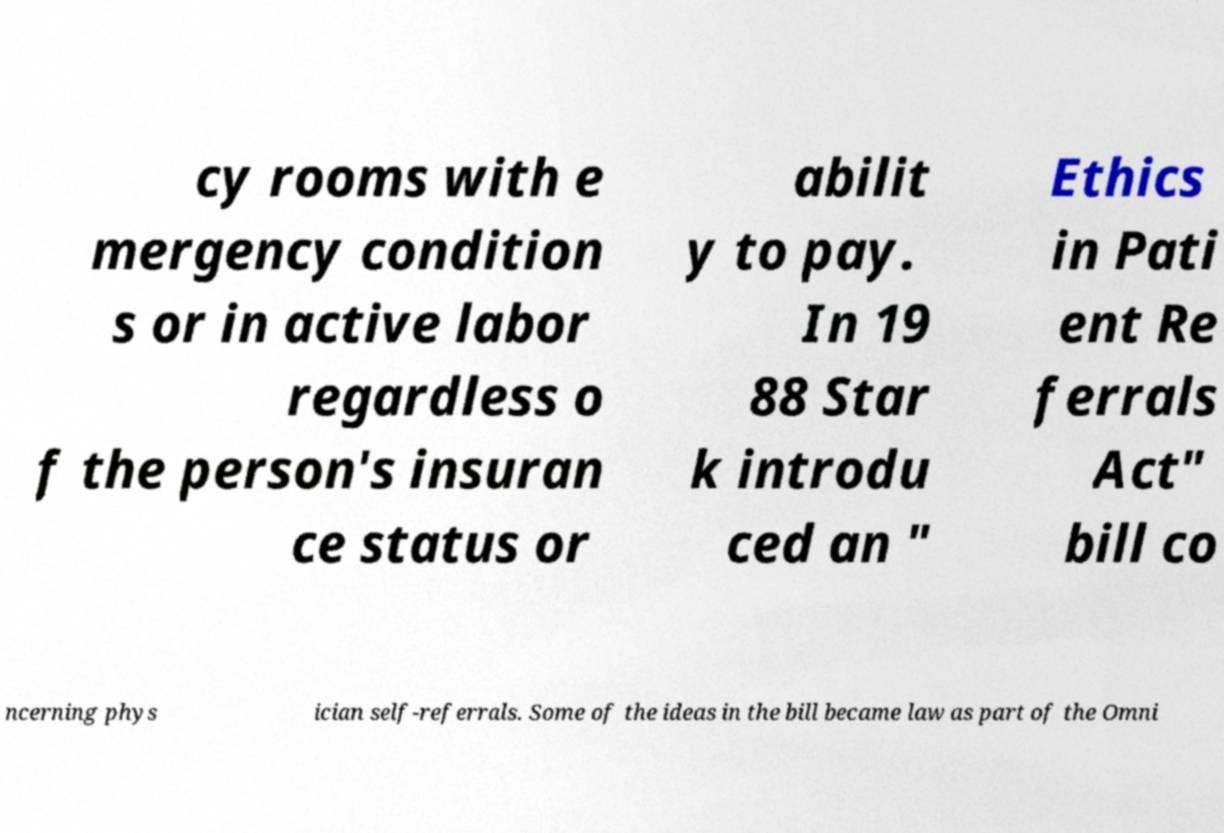Can you read and provide the text displayed in the image?This photo seems to have some interesting text. Can you extract and type it out for me? cy rooms with e mergency condition s or in active labor regardless o f the person's insuran ce status or abilit y to pay. In 19 88 Star k introdu ced an " Ethics in Pati ent Re ferrals Act" bill co ncerning phys ician self-referrals. Some of the ideas in the bill became law as part of the Omni 